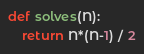<code> <loc_0><loc_0><loc_500><loc_500><_Python_>def solves(N):
	return N*(N-1) / 2</code> 